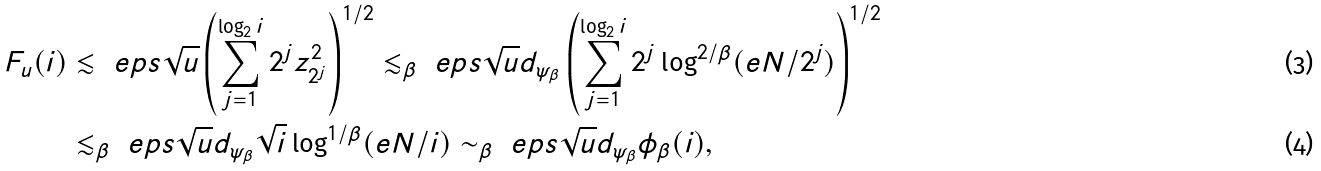<formula> <loc_0><loc_0><loc_500><loc_500>F _ { u } ( i ) & \lesssim \ e p s \sqrt { u } \left ( \sum _ { j = 1 } ^ { \log _ { 2 } i } 2 ^ { j } z _ { 2 ^ { j } } ^ { 2 } \right ) ^ { 1 / 2 } \lesssim _ { \beta } \ e p s \sqrt { u } d _ { \psi _ { \beta } } \left ( \sum _ { j = 1 } ^ { \log _ { 2 } i } 2 ^ { j } \log ^ { 2 / \beta } ( e N / 2 ^ { j } ) \right ) ^ { 1 / 2 } \\ & \lesssim _ { \beta } \ e p s \sqrt { u } d _ { \psi _ { \beta } } \sqrt { i } \log ^ { 1 / \beta } ( e N / i ) \sim _ { \beta } \ e p s \sqrt { u } d _ { \psi _ { \beta } } \phi _ { \beta } ( i ) ,</formula> 